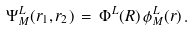<formula> <loc_0><loc_0><loc_500><loc_500>\Psi _ { M } ^ { L } ( { r } _ { 1 } , { r } _ { 2 } ) \, = \, \Phi ^ { L } ( { R } ) \, \phi _ { M } ^ { L } ( { r } ) \, .</formula> 